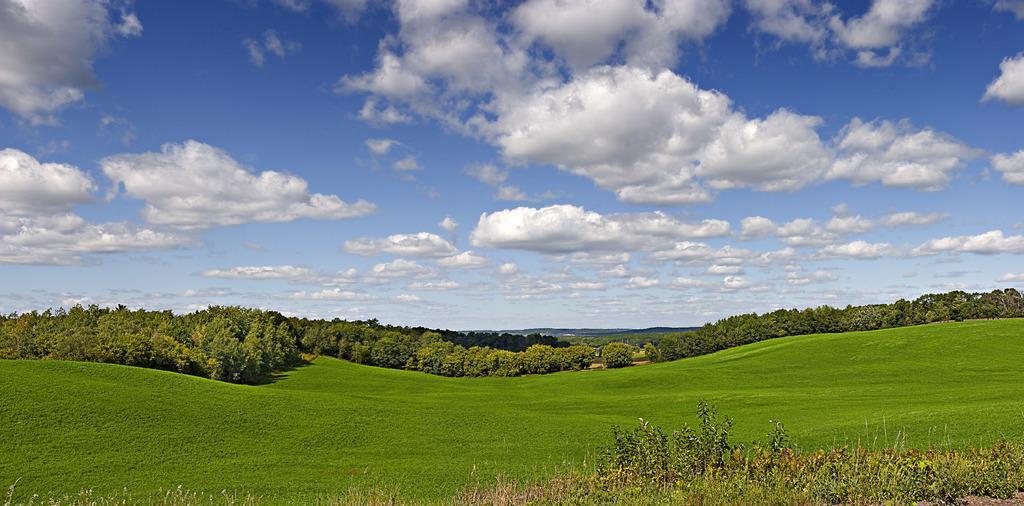Please provide a concise description of this image. In this image we can see there is a beautiful view of clouds in the sky, grass and trees in the ground. 